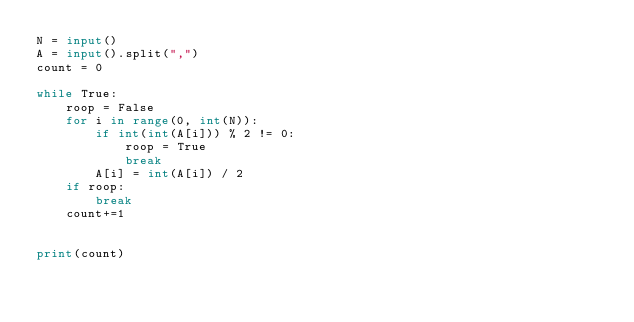<code> <loc_0><loc_0><loc_500><loc_500><_Python_>N = input()
A = input().split(",")
count = 0

while True:
    roop = False
    for i in range(0, int(N)):
        if int(int(A[i])) % 2 != 0:
            roop = True
            break
        A[i] = int(A[i]) / 2
    if roop:
        break
    count+=1


print(count)

        

  </code> 